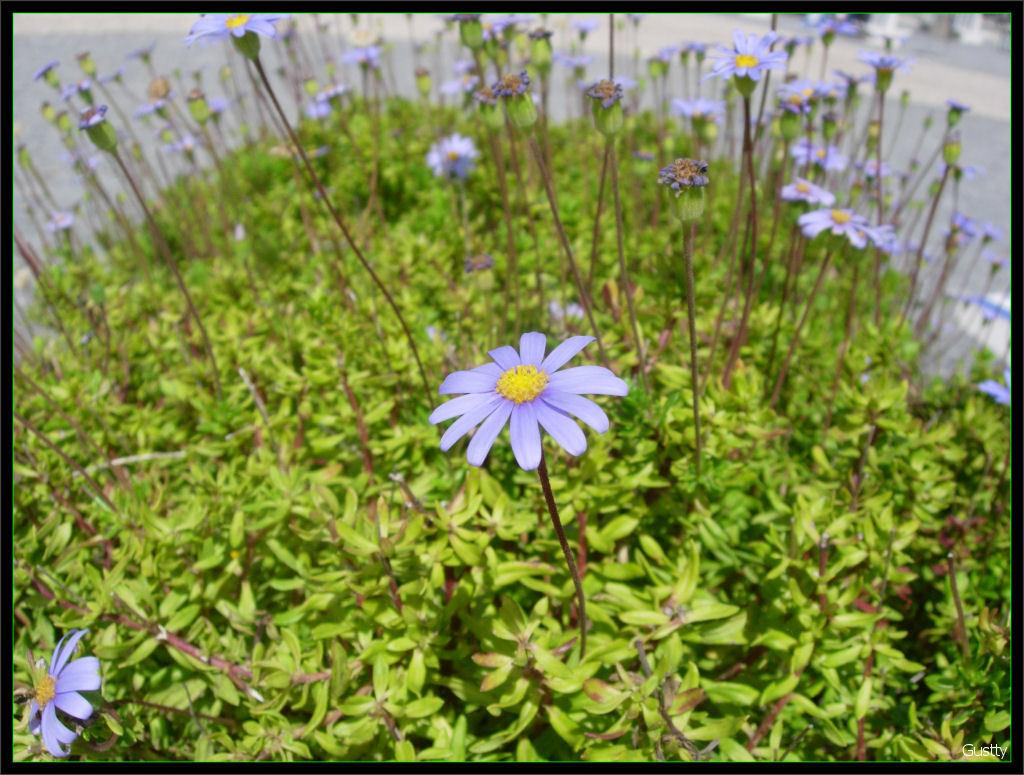What type of plants can be seen in the image? There are plants with flowers in the image. What can be seen in the background of the image? There is a road visible in the background of the image. How many chickens are present in the image? There are no chickens present in the image. What type of agreement is being discussed in the image? There is no discussion or agreement present in the image; it features plants with flowers and a road in the background. 